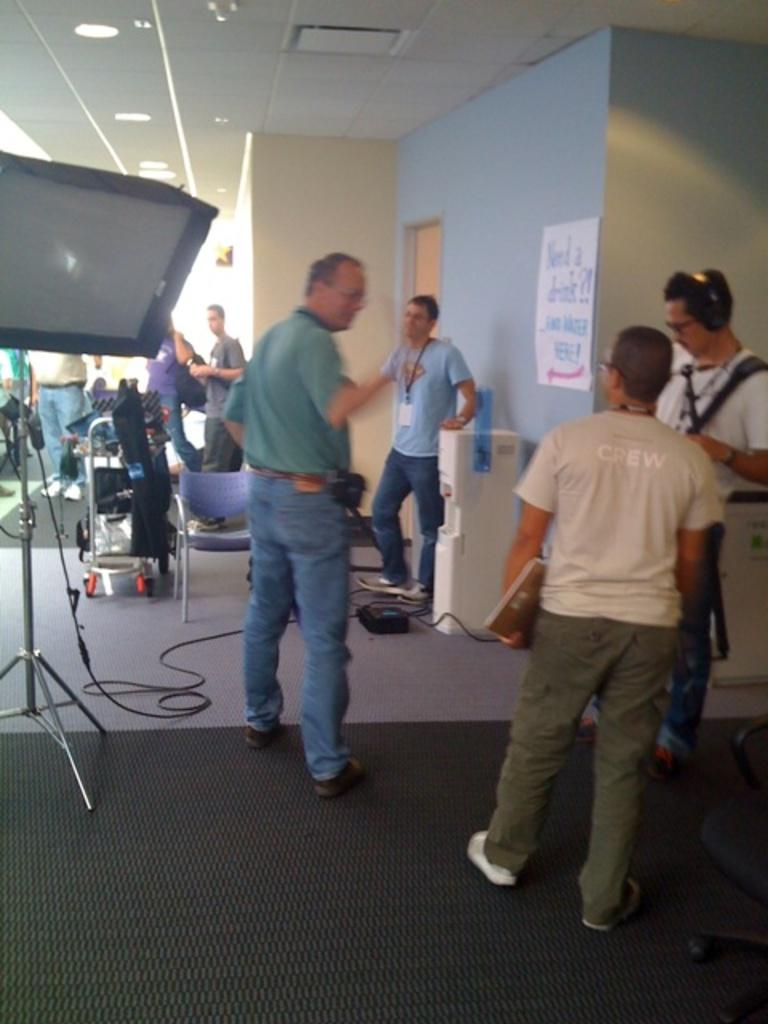What are the people in the image doing? The people in the image are standing on the floor. What type of furniture is present in the image? There are chairs in the image. What structure can be seen in the image? There is a stand in the image. What is connected to the stand? There is a cable in the image that is connected to the stand. What device is present for providing water? There is a water dispenser in the image. What type of decoration is on the wall? There is a poster in the image. What encloses the space in the image? There are walls in the image. What is above the space in the image? There is a ceiling in the image. What provides illumination in the image? There are lights in the image. What other objects can be seen in the image? There are other objects in the image, but their specific details are not mentioned in the provided facts. What type of weather can be seen in the image? The provided facts do not mention any weather conditions, so it cannot be determined from the image. Are there any ghosts visible in the image? There are no ghosts present in the image; only the people, chairs, stand, cable, water dispenser, poster, walls, ceiling, lights, and other objects are visible. How many cherries are on the poster in the image? There is no mention of cherries in the provided facts, so it cannot be determined from the image. 